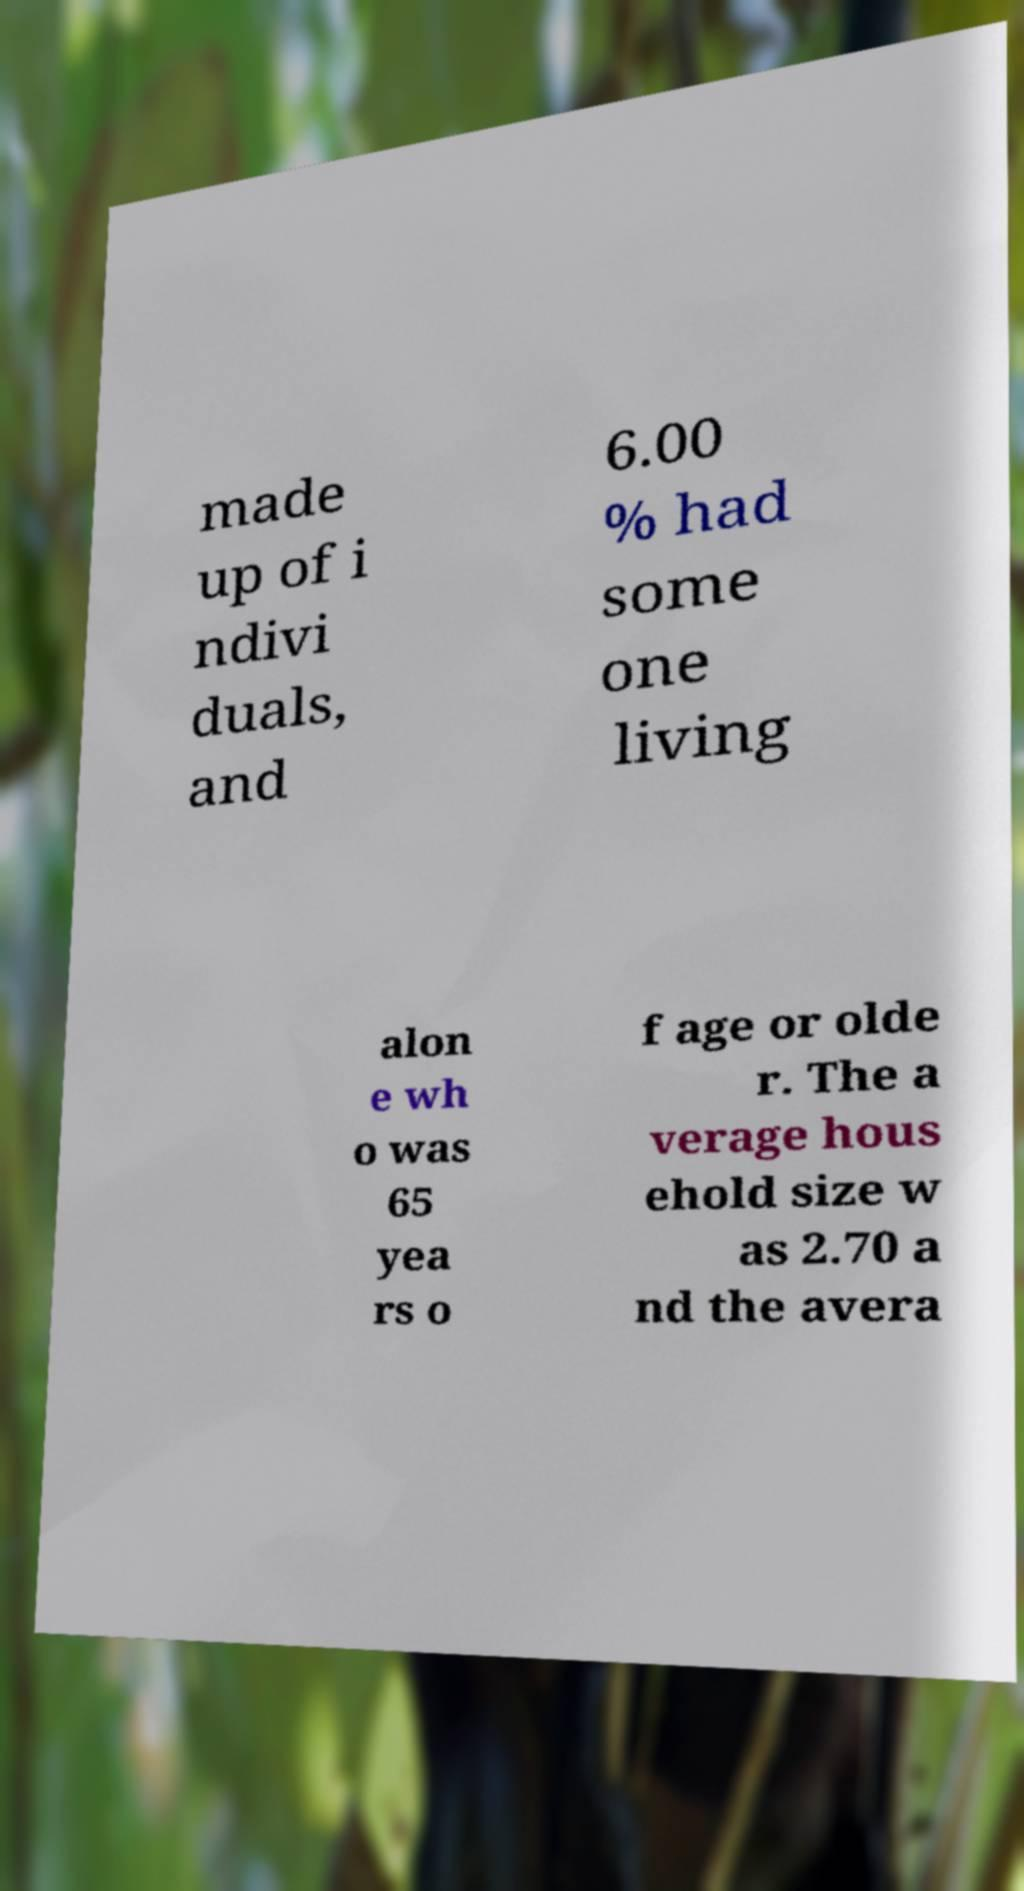There's text embedded in this image that I need extracted. Can you transcribe it verbatim? made up of i ndivi duals, and 6.00 % had some one living alon e wh o was 65 yea rs o f age or olde r. The a verage hous ehold size w as 2.70 a nd the avera 